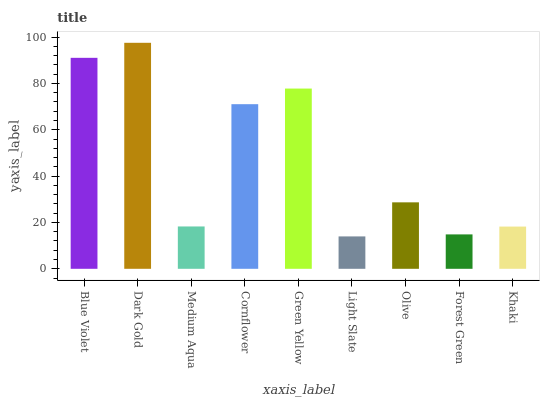Is Light Slate the minimum?
Answer yes or no. Yes. Is Dark Gold the maximum?
Answer yes or no. Yes. Is Medium Aqua the minimum?
Answer yes or no. No. Is Medium Aqua the maximum?
Answer yes or no. No. Is Dark Gold greater than Medium Aqua?
Answer yes or no. Yes. Is Medium Aqua less than Dark Gold?
Answer yes or no. Yes. Is Medium Aqua greater than Dark Gold?
Answer yes or no. No. Is Dark Gold less than Medium Aqua?
Answer yes or no. No. Is Olive the high median?
Answer yes or no. Yes. Is Olive the low median?
Answer yes or no. Yes. Is Light Slate the high median?
Answer yes or no. No. Is Forest Green the low median?
Answer yes or no. No. 